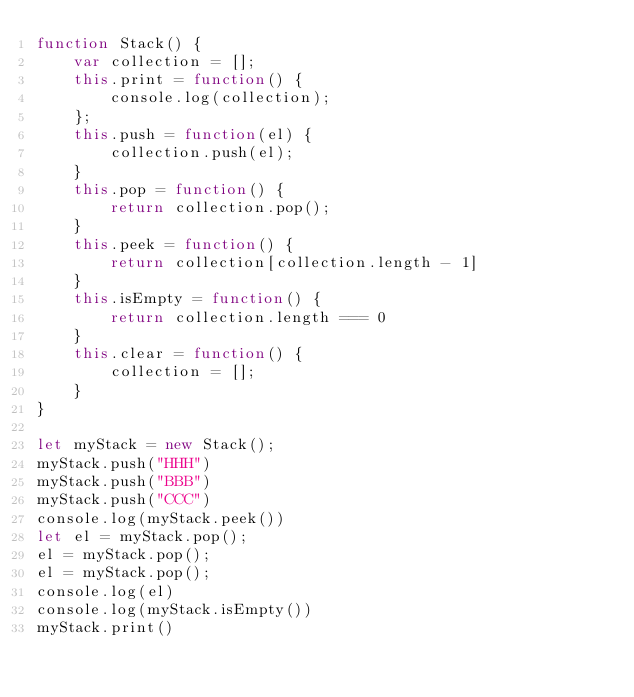<code> <loc_0><loc_0><loc_500><loc_500><_JavaScript_>function Stack() {
	var collection = [];
	this.print = function() {
		console.log(collection);
	};
	this.push = function(el) {
		collection.push(el);
	}
	this.pop = function() {
		return collection.pop();
	}
	this.peek = function() {
		return collection[collection.length - 1]
	}
	this.isEmpty = function() {
		return collection.length === 0
	}
	this.clear = function() {
		collection = [];
	}
}
  
let myStack = new Stack();
myStack.push("HHH")
myStack.push("BBB")
myStack.push("CCC")
console.log(myStack.peek())
let el = myStack.pop();
el = myStack.pop();
el = myStack.pop();
console.log(el)
console.log(myStack.isEmpty())
myStack.print()</code> 